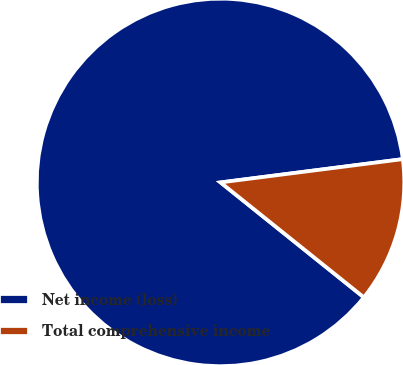<chart> <loc_0><loc_0><loc_500><loc_500><pie_chart><fcel>Net income (loss)<fcel>Total comprehensive income<nl><fcel>87.22%<fcel>12.78%<nl></chart> 